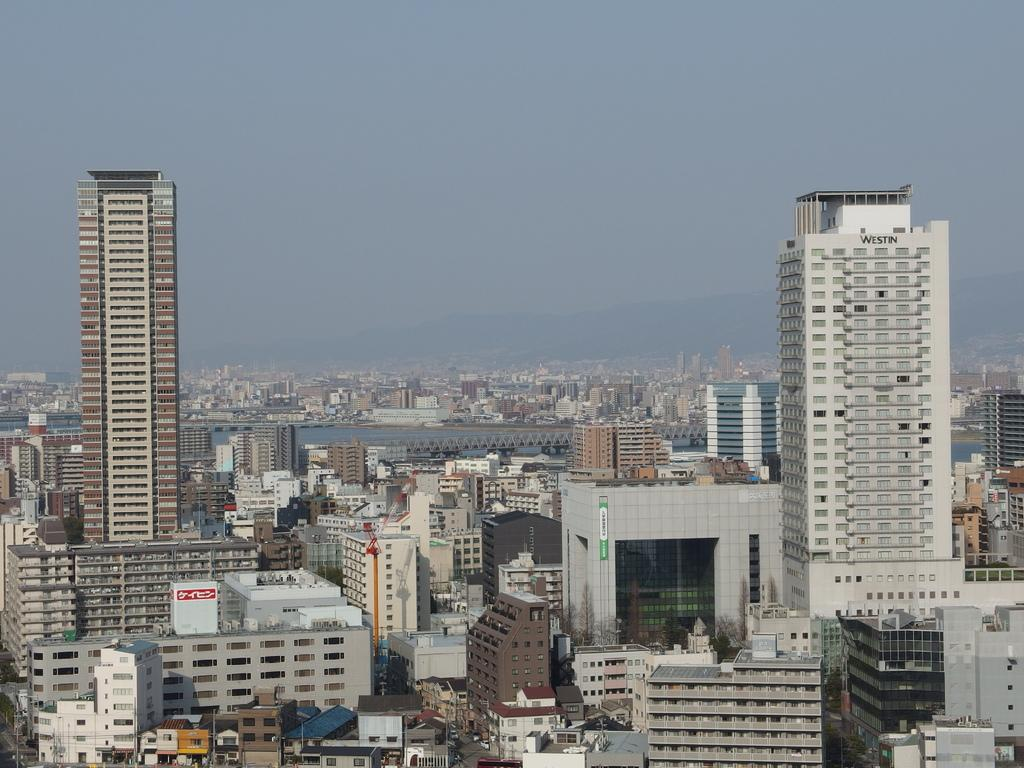What type of buildings are in the foreground of the image? There are skyscrapers in the foreground of the image. What part of the natural environment is visible in the image? The sky is visible in the background of the image. What type of slave is depicted in the image? There is no slave depicted in the image; it features skyscrapers and the sky. What is the value of the maid in the image? There is no maid present in the image, so it is not possible to determine its value. 